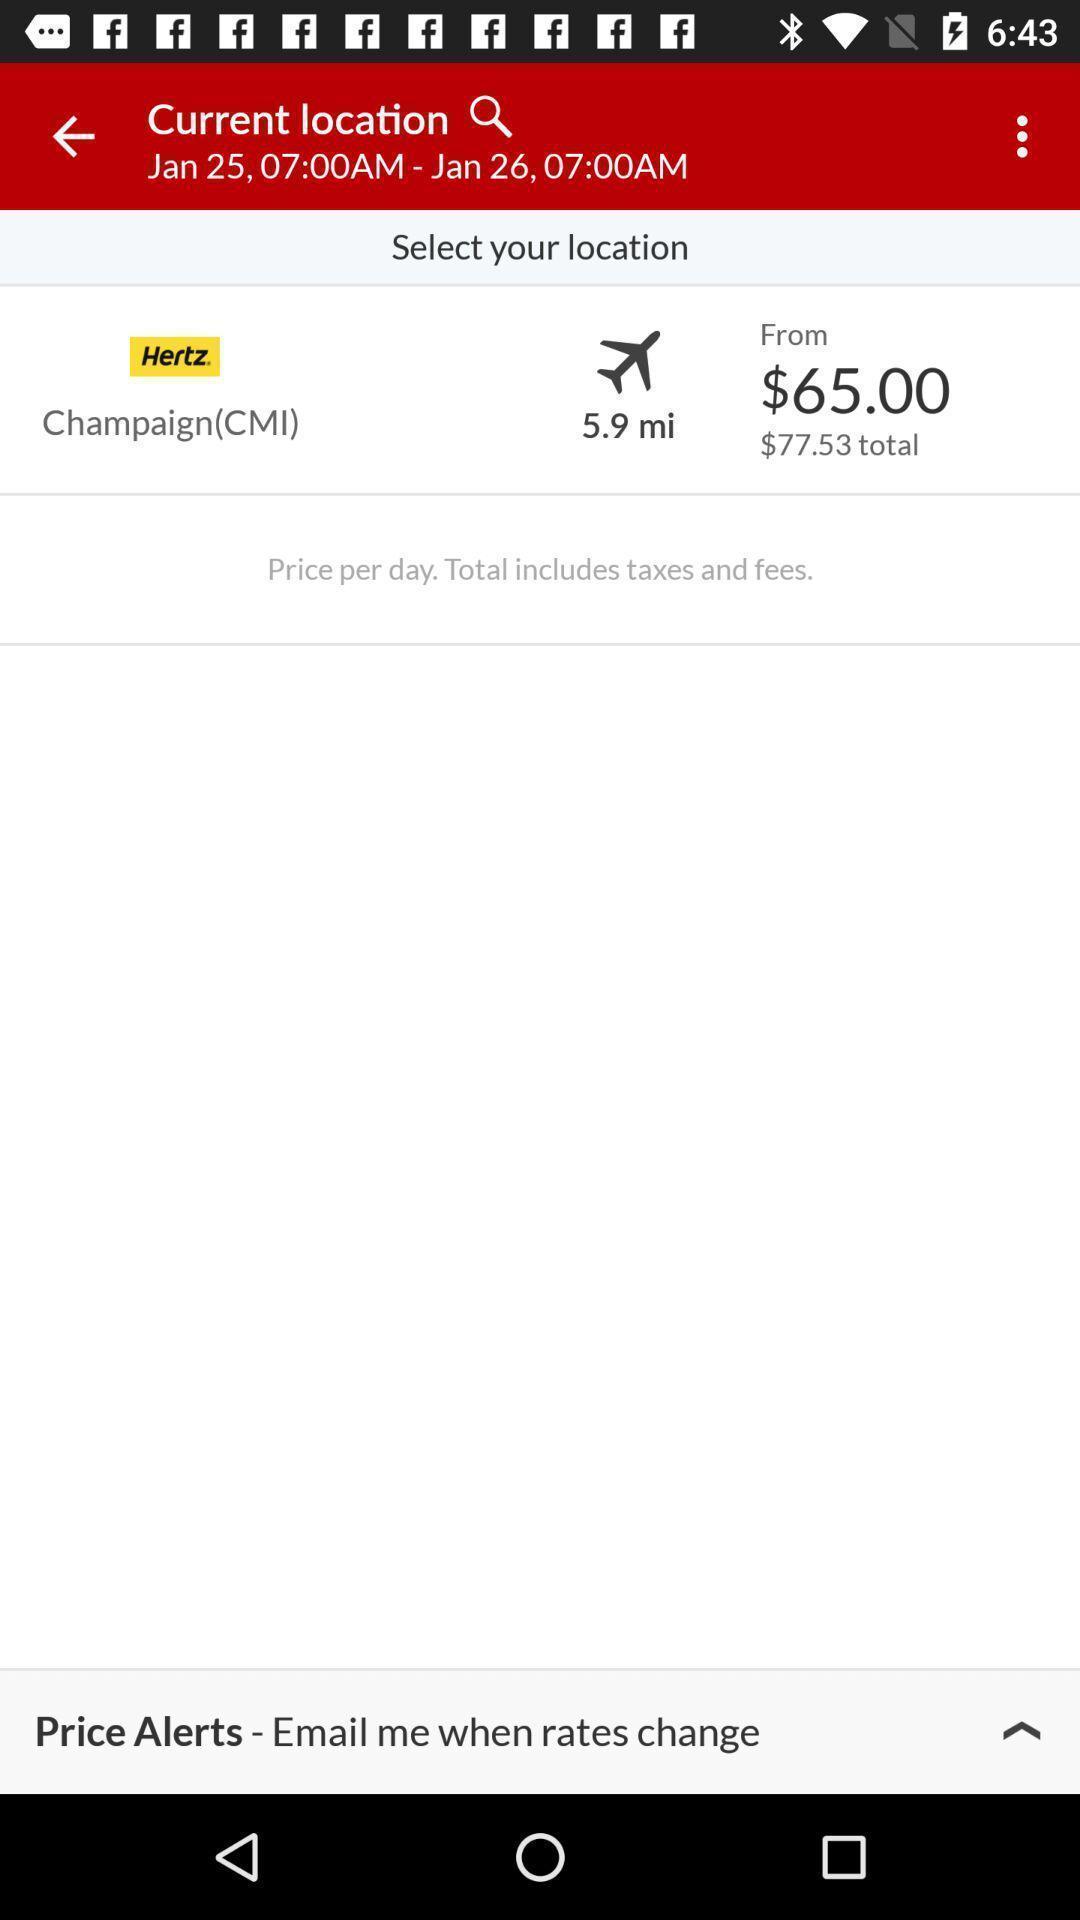Provide a textual representation of this image. Screen showing search bar to find location. 